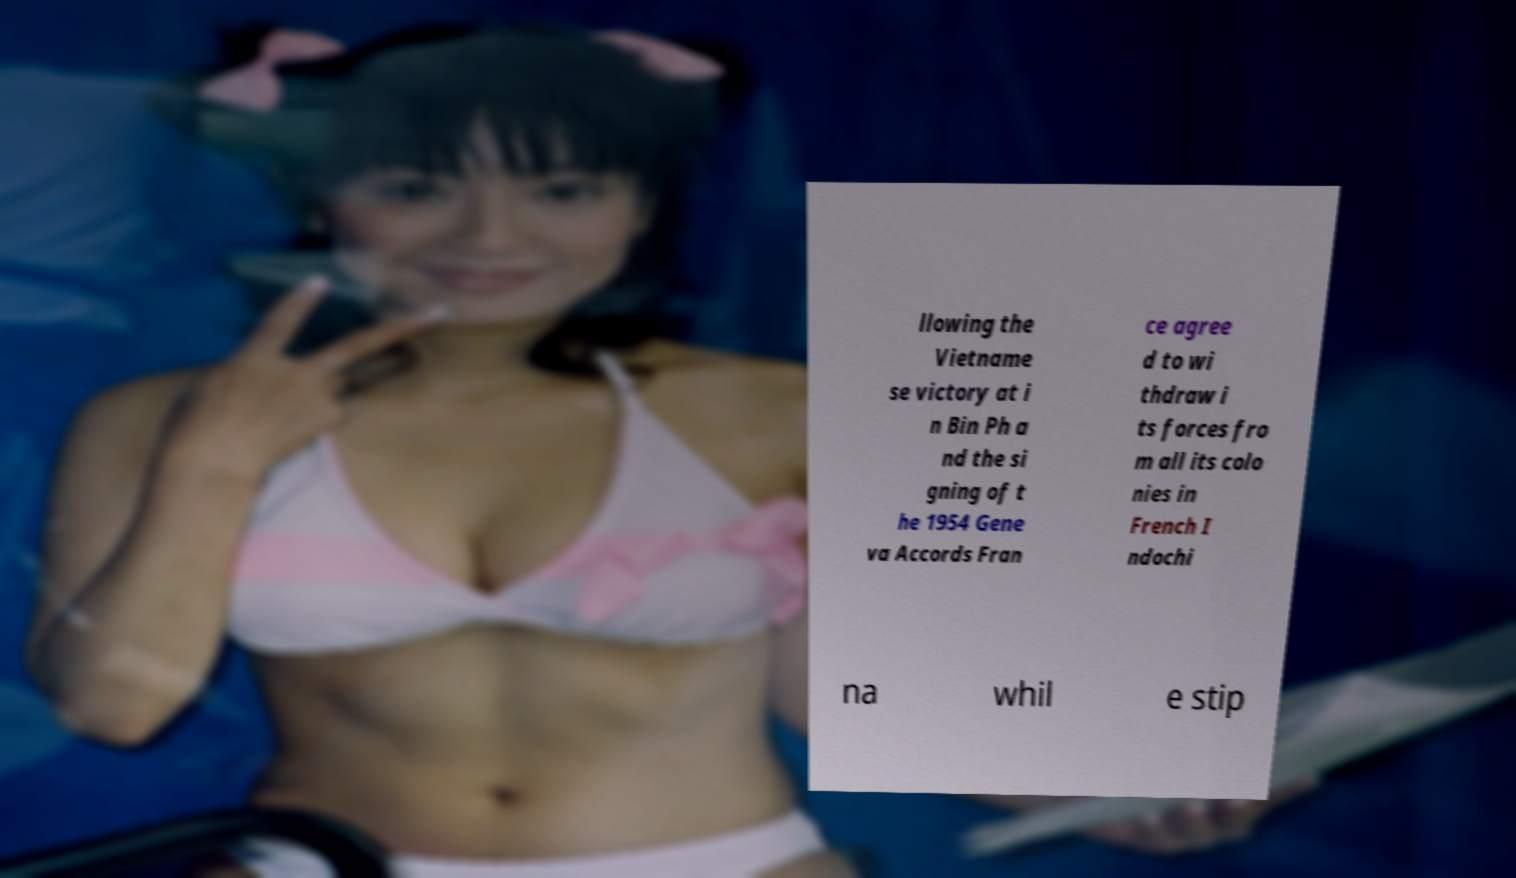Can you accurately transcribe the text from the provided image for me? llowing the Vietname se victory at i n Bin Ph a nd the si gning of t he 1954 Gene va Accords Fran ce agree d to wi thdraw i ts forces fro m all its colo nies in French I ndochi na whil e stip 